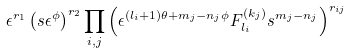<formula> <loc_0><loc_0><loc_500><loc_500>\epsilon ^ { r _ { 1 } } \left ( s \epsilon ^ { \phi } \right ) ^ { r _ { 2 } } \prod _ { i , j } \left ( \epsilon ^ { ( l _ { i } + 1 ) \theta + m _ { j } - n _ { j } \phi } F _ { l _ { i } } ^ { ( k _ { j } ) } s ^ { m _ { j } - n _ { j } } \right ) ^ { r _ { i j } }</formula> 